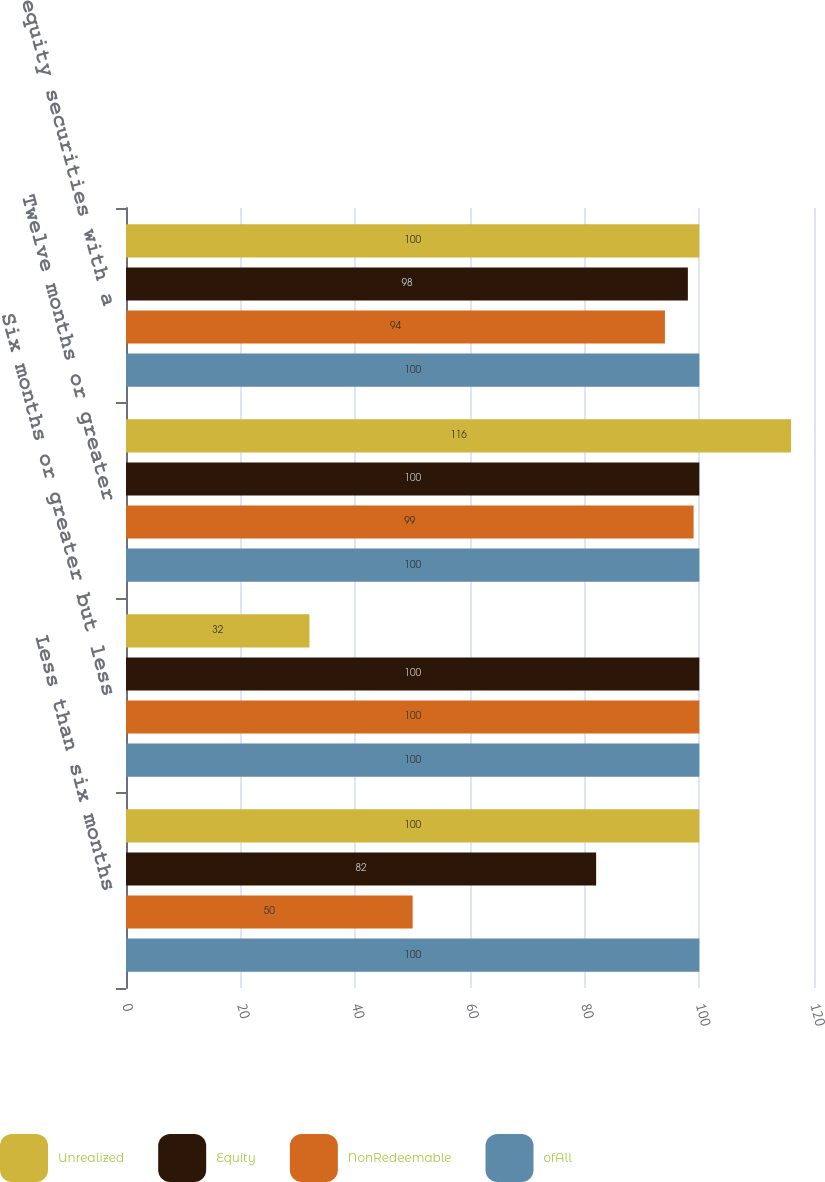Convert chart to OTSL. <chart><loc_0><loc_0><loc_500><loc_500><stacked_bar_chart><ecel><fcel>Less than six months<fcel>Six months or greater but less<fcel>Twelve months or greater<fcel>All equity securities with a<nl><fcel>Unrealized<fcel>100<fcel>32<fcel>116<fcel>100<nl><fcel>Equity<fcel>82<fcel>100<fcel>100<fcel>98<nl><fcel>NonRedeemable<fcel>50<fcel>100<fcel>99<fcel>94<nl><fcel>ofAll<fcel>100<fcel>100<fcel>100<fcel>100<nl></chart> 